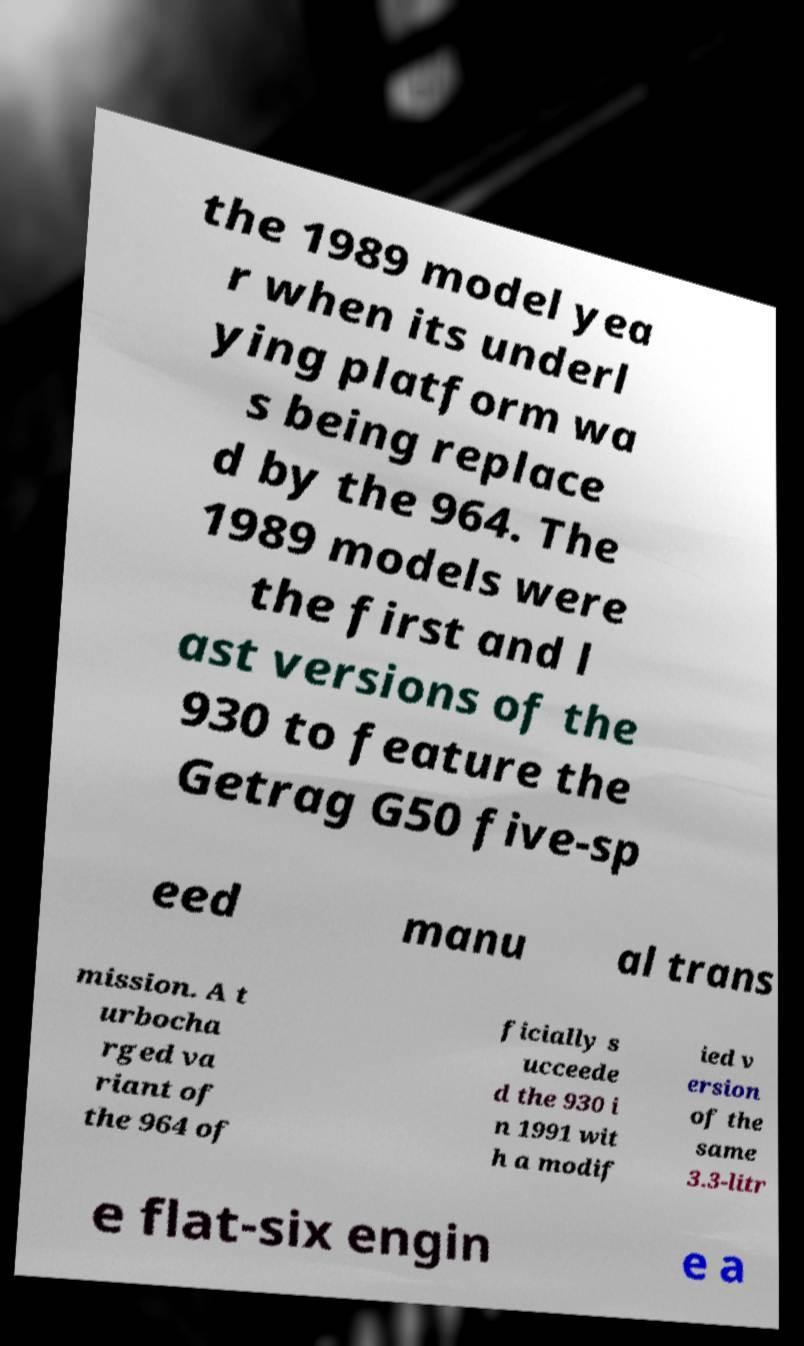Could you assist in decoding the text presented in this image and type it out clearly? the 1989 model yea r when its underl ying platform wa s being replace d by the 964. The 1989 models were the first and l ast versions of the 930 to feature the Getrag G50 five-sp eed manu al trans mission. A t urbocha rged va riant of the 964 of ficially s ucceede d the 930 i n 1991 wit h a modif ied v ersion of the same 3.3-litr e flat-six engin e a 